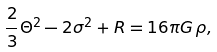Convert formula to latex. <formula><loc_0><loc_0><loc_500><loc_500>\frac { 2 } { 3 } \Theta ^ { 2 } - 2 \sigma ^ { 2 } + R = 1 6 \pi G \, \rho ,</formula> 